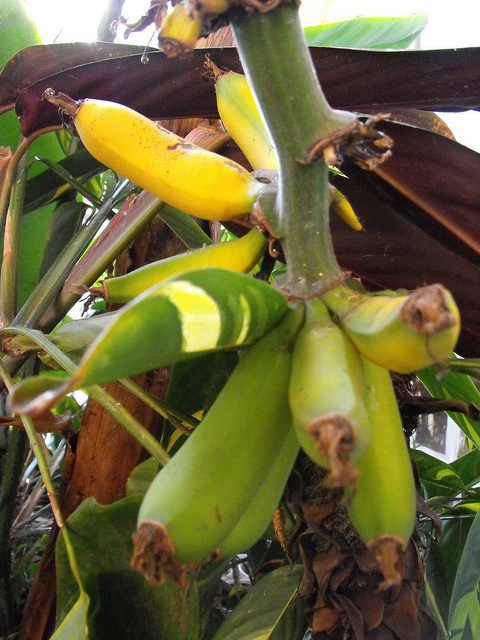Describe the objects in this image and their specific colors. I can see banana in beige and olive tones, banana in beige, darkgreen, olive, and khaki tones, banana in beige, gold, orange, and khaki tones, banana in beige, tan, and olive tones, and banana in beige, olive, and black tones in this image. 